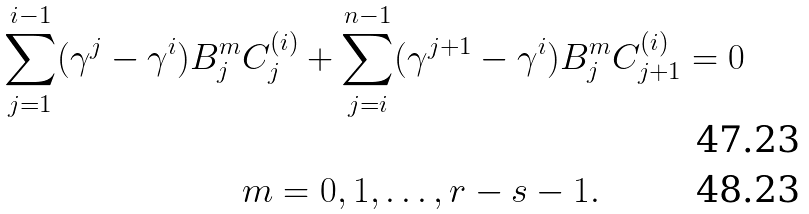Convert formula to latex. <formula><loc_0><loc_0><loc_500><loc_500>\sum _ { j = 1 } ^ { i - 1 } ( \gamma ^ { j } - \gamma ^ { i } ) B _ { j } ^ { m } & C _ { j } ^ { ( i ) } + \sum _ { j = i } ^ { n - 1 } ( \gamma ^ { j + 1 } - \gamma ^ { i } ) B _ { j } ^ { m } C _ { j + 1 } ^ { ( i ) } = 0 \\ & m = 0 , 1 , \dots , r - s - 1 .</formula> 